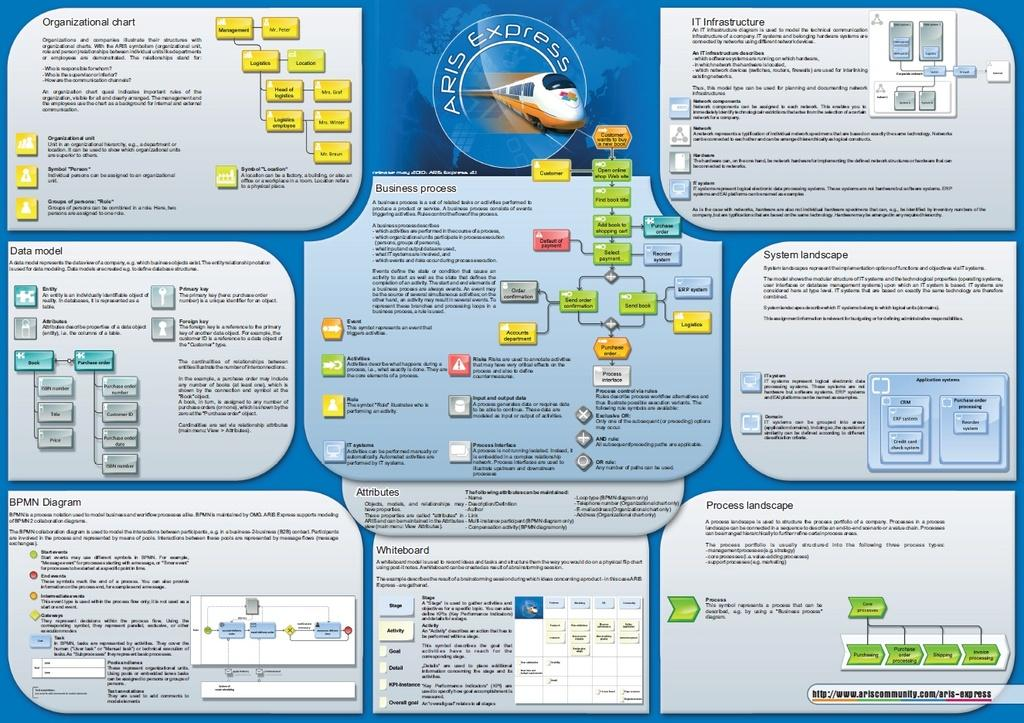What is the main subject in the center of the image? There is a poster in the center of the image. What is depicted on the poster? The poster contains an image of a train. Are there any words on the poster? Yes, there is text on the poster. What type of locket can be seen hanging from the train in the image? There is no locket present in the image, and the train is not depicted as having any accessories. 